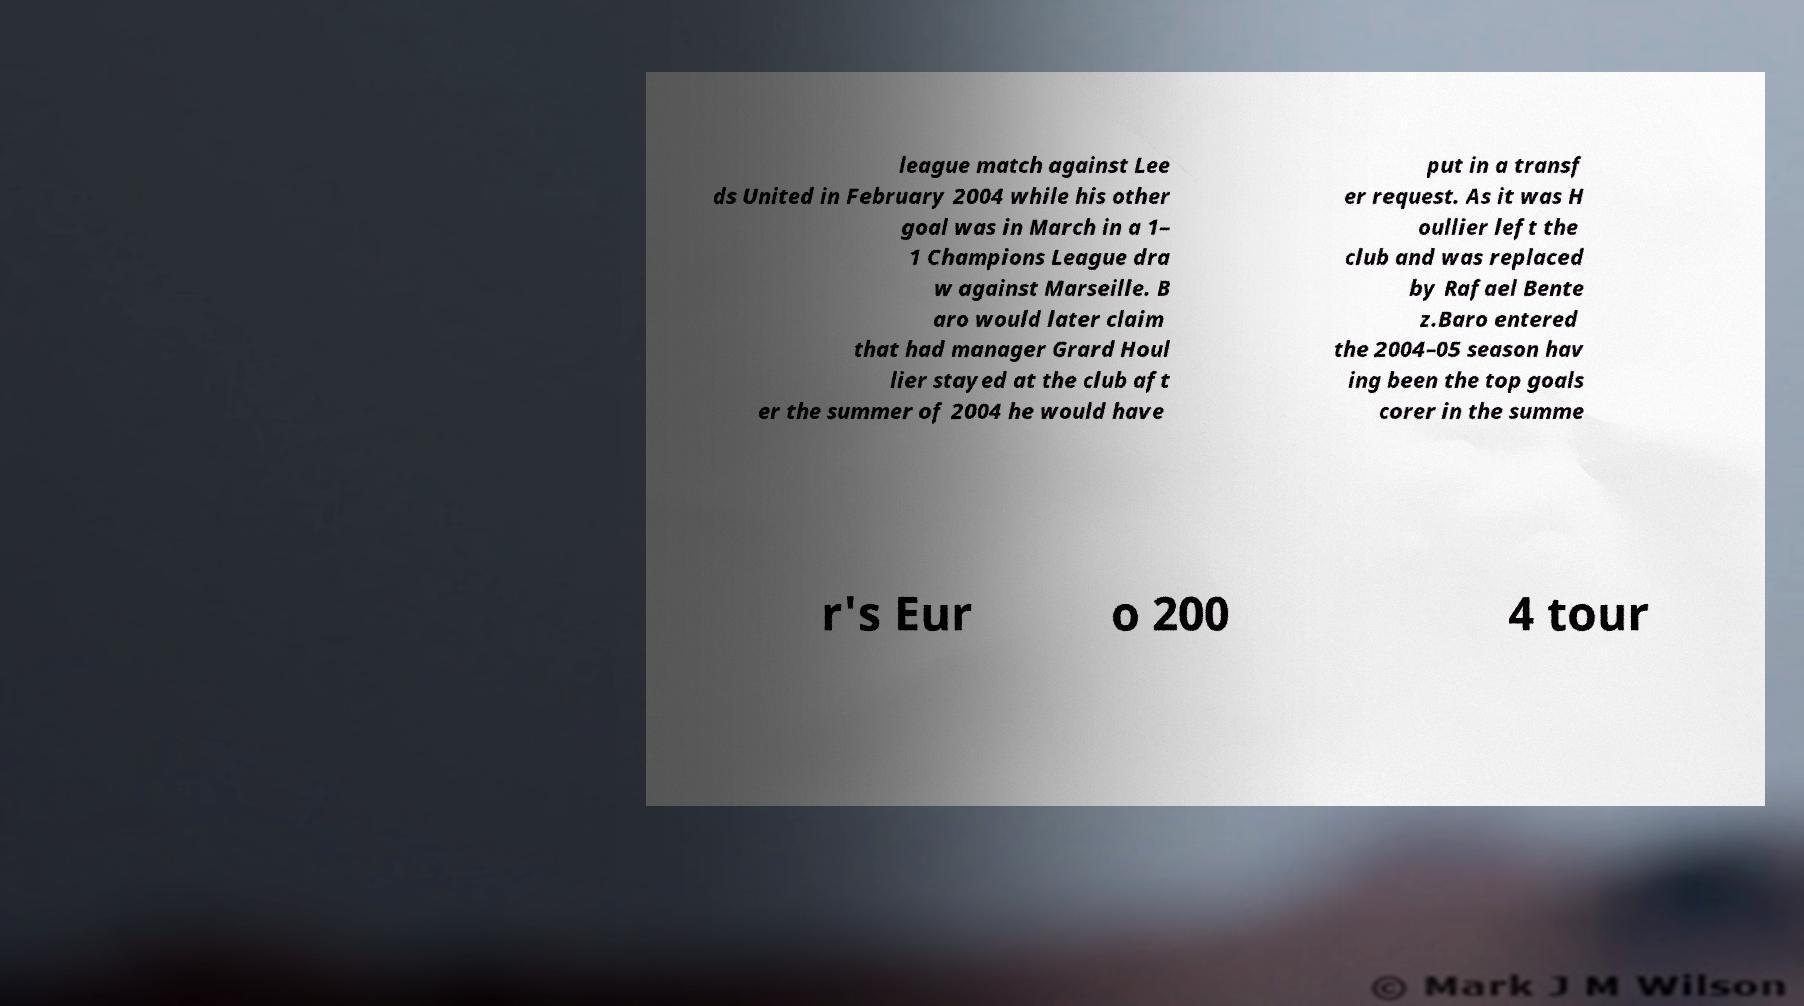Can you read and provide the text displayed in the image?This photo seems to have some interesting text. Can you extract and type it out for me? league match against Lee ds United in February 2004 while his other goal was in March in a 1– 1 Champions League dra w against Marseille. B aro would later claim that had manager Grard Houl lier stayed at the club aft er the summer of 2004 he would have put in a transf er request. As it was H oullier left the club and was replaced by Rafael Bente z.Baro entered the 2004–05 season hav ing been the top goals corer in the summe r's Eur o 200 4 tour 